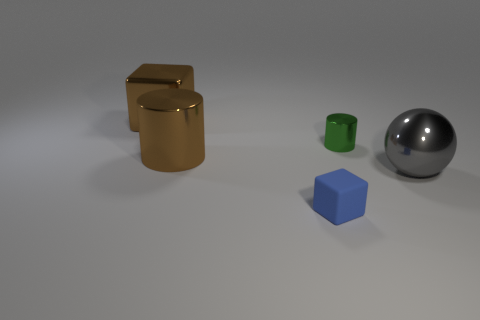Add 1 metal cylinders. How many objects exist? 6 Subtract all balls. How many objects are left? 4 Subtract 0 gray cylinders. How many objects are left? 5 Subtract all big gray spheres. Subtract all tiny blue things. How many objects are left? 3 Add 3 tiny green metal objects. How many tiny green metal objects are left? 4 Add 1 blocks. How many blocks exist? 3 